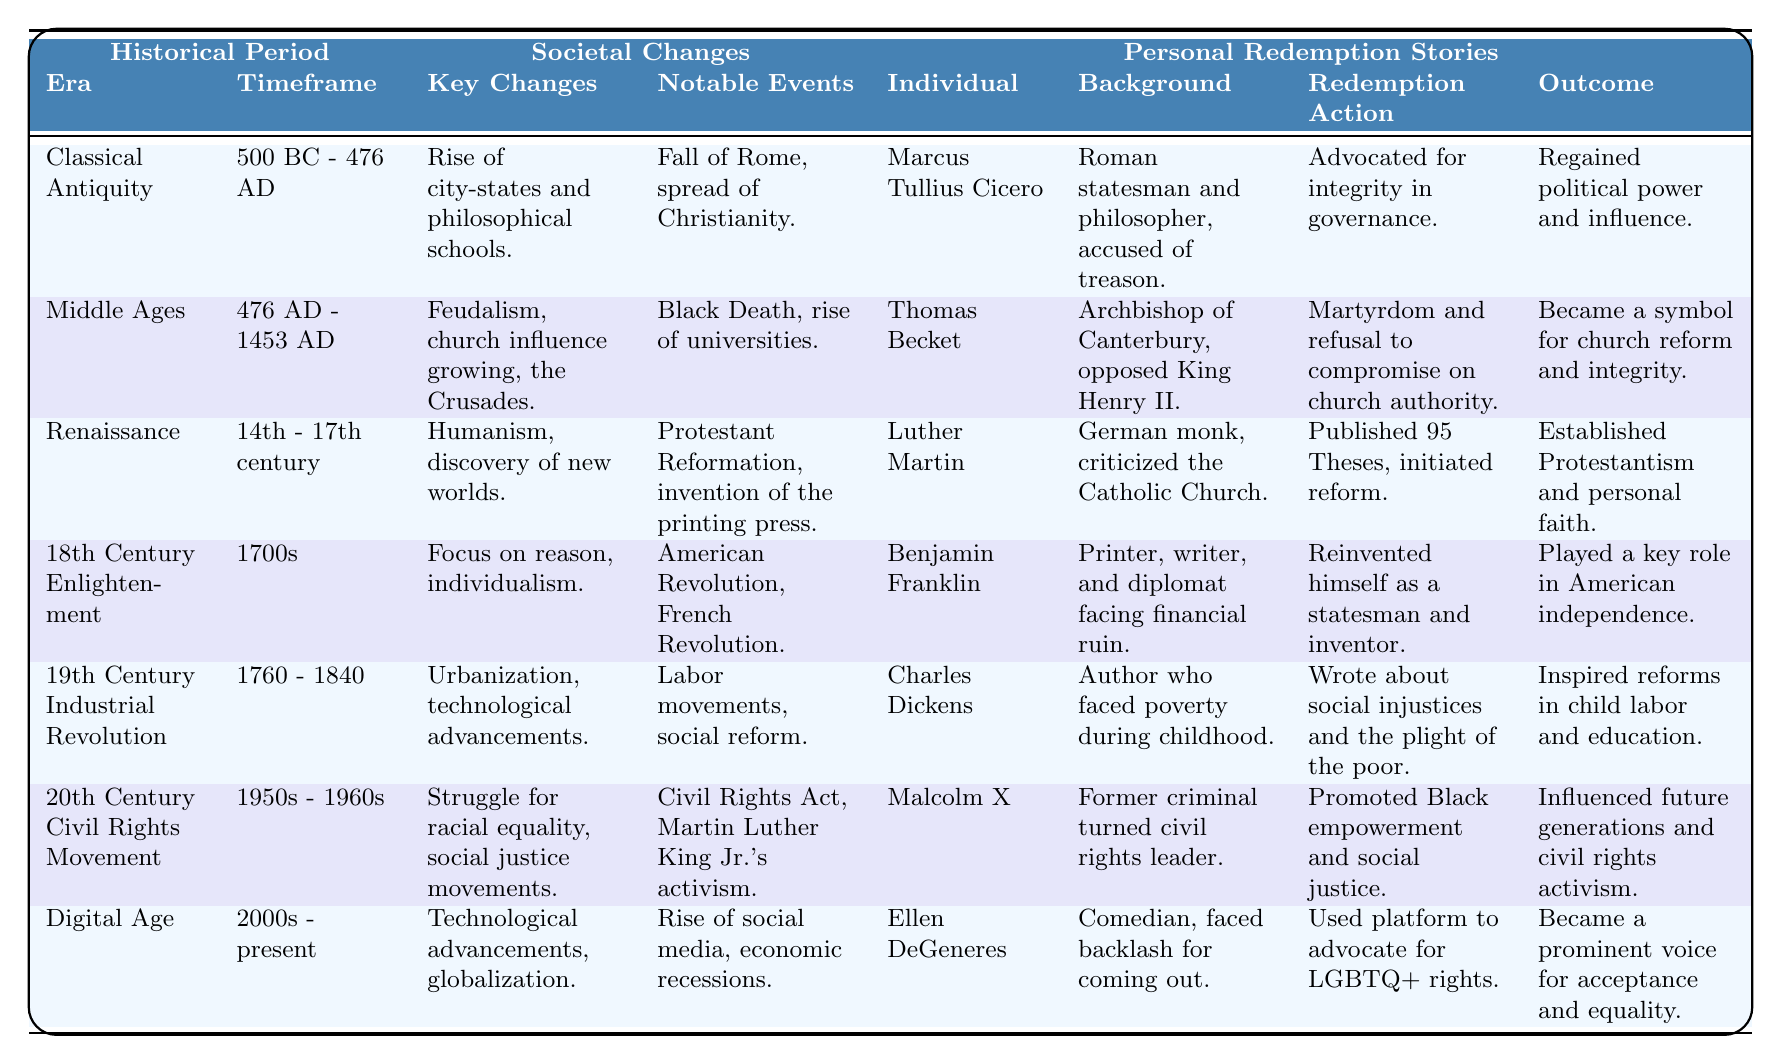What is the time frame of the Renaissance era? The table specifies that the Renaissance era spans from the 14th to the 17th century, as noted in the respective column’s timeframe.
Answer: 14th - 17th century Who is the individual associated with the 18th Century Enlightenment? The table indicates that Benjamin Franklin is the individual associated with the 18th Century Enlightenment within the Personal Redemption Stories section.
Answer: Benjamin Franklin Did Marcus Tullius Cicero regain political power after his actions? According to the table, Cicero’s redemption action of advocating for integrity in governance led to him regaining political power and influence. Thus, the statement is true.
Answer: Yes Which historical period experienced the rise of social media? The Digital Age, as shown in the table, is the historical period experiencing the rise of social media, highlighted within its notable events.
Answer: Digital Age How many individuals are noted in the 19th Century Industrial Revolution? The table lists only one individual, Charles Dickens, in the Personal Redemption Stories section for the 19th Century Industrial Revolution, indicating there is just one noted individual.
Answer: One What outcome did Malcolm X achieve through his redemption action? The table specifies that Malcolm X's redemption action of promoting Black empowerment resulted in influencing future generations and civil rights activism, reflecting a significant outcome.
Answer: Influenced future generations Can you compare the societal changes in the Classical Antiquity and Middle Ages? The Classical Antiquity era experienced the rise of city-states and philosophical schools, while the Middle Ages saw growing church influence and feudalism. Hence, the societal changes differed significantly between these two periods in focus and impact.
Answer: Yes, they differ significantly What role did 'social reforms' play in Charles Dickens's redemption story? Dickens faced poverty and wrote about social injustices in his redemption story, which is described in the outcomes and shows that his writing inspired reforms in child labor and education as a consequence of societal changes during the Industrial Revolution.
Answer: Inspired reforms in child labor and education In which historical period did the Black Death occur? The Middle Ages, as mentioned in the notable events column of the table, is where the Black Death emerged, significantly impacting societal structures at that time.
Answer: Middle Ages How does the redemption action of Ellen DeGeneres compare with that of Malcolm X? Ellen DeGeneres used her platform to advocate for LGBTQ+ rights, while Malcolm X promoted Black empowerment and social justice. Both used their personal experiences and public platforms for advocacy, but they focused on different social justice issues.
Answer: Both advocated for social justice but focused on different communities 